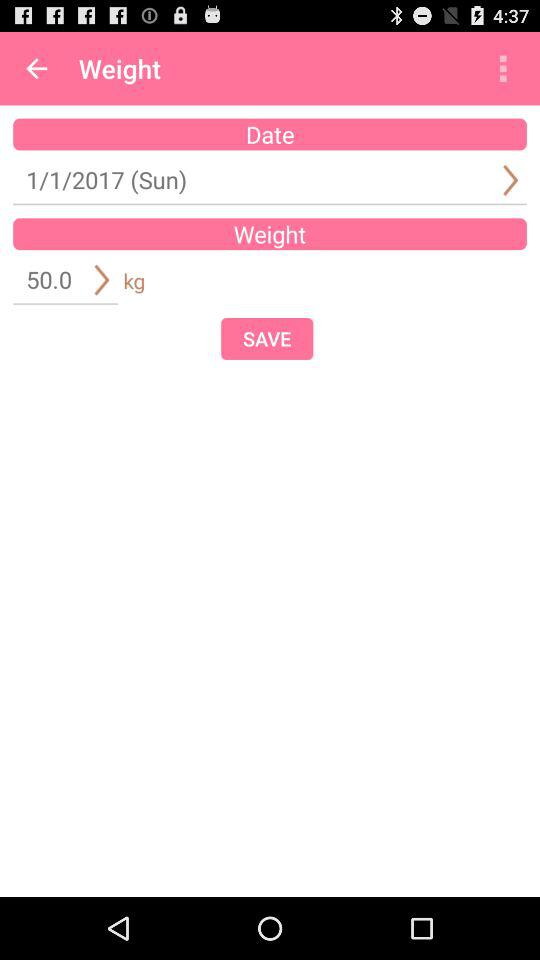What is the weight in kg?
Answer the question using a single word or phrase. 50.0 